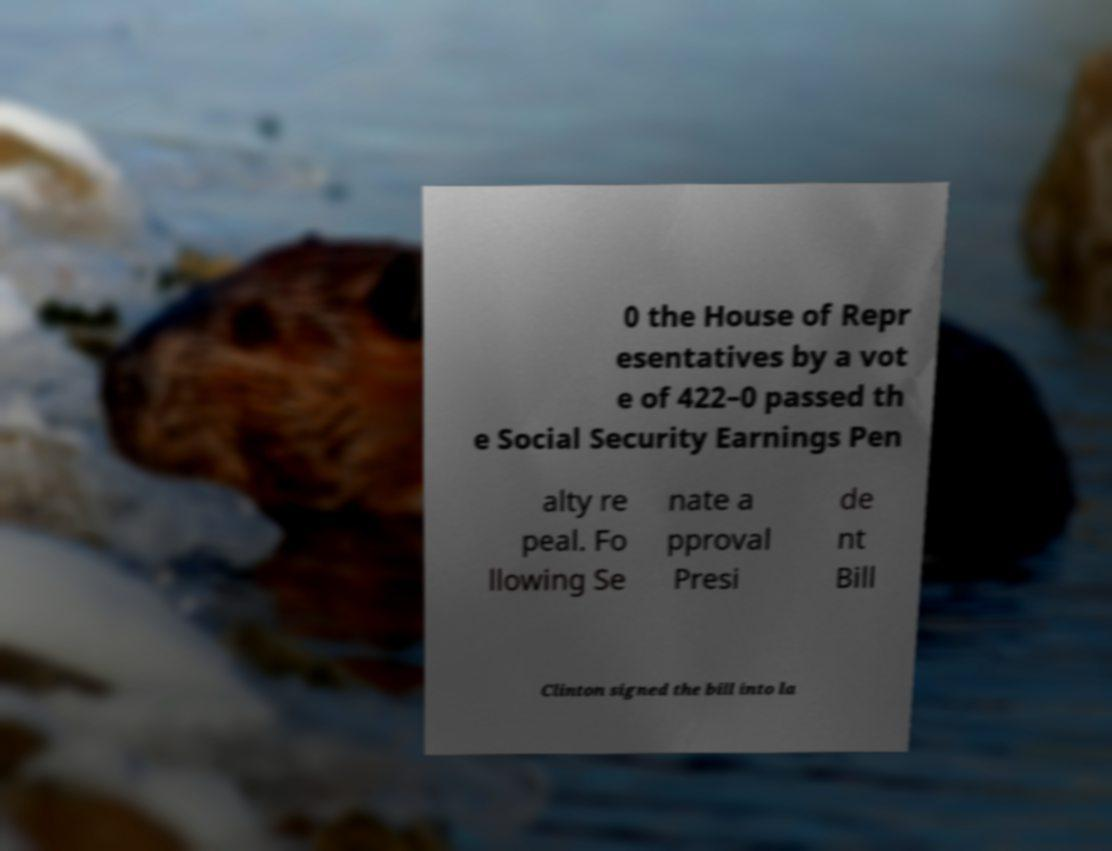For documentation purposes, I need the text within this image transcribed. Could you provide that? 0 the House of Repr esentatives by a vot e of 422–0 passed th e Social Security Earnings Pen alty re peal. Fo llowing Se nate a pproval Presi de nt Bill Clinton signed the bill into la 